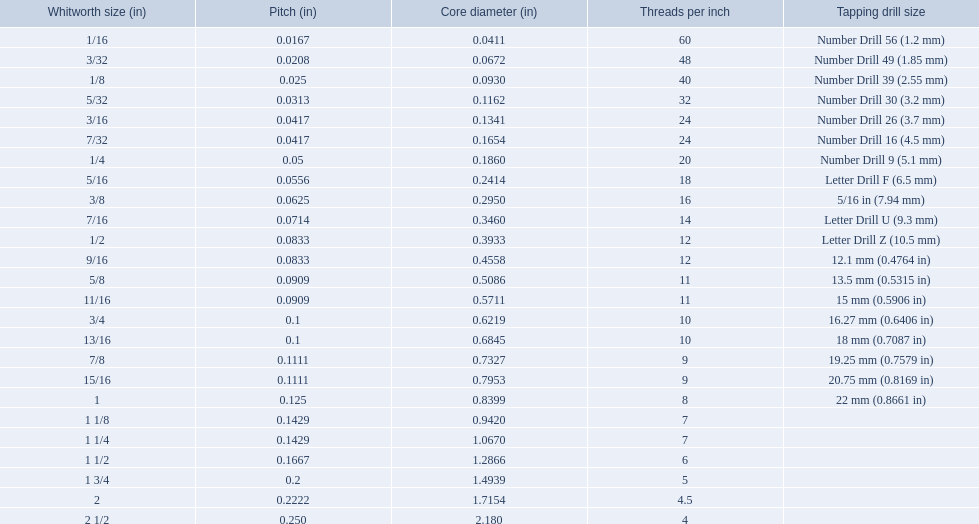What are all the whitworth sizes? 1/16, 3/32, 1/8, 5/32, 3/16, 7/32, 1/4, 5/16, 3/8, 7/16, 1/2, 9/16, 5/8, 11/16, 3/4, 13/16, 7/8, 15/16, 1, 1 1/8, 1 1/4, 1 1/2, 1 3/4, 2, 2 1/2. Can you give me this table as a dict? {'header': ['Whitworth size (in)', 'Pitch (in)', 'Core diameter (in)', 'Threads per\xa0inch', 'Tapping drill size'], 'rows': [['1/16', '0.0167', '0.0411', '60', 'Number Drill 56 (1.2\xa0mm)'], ['3/32', '0.0208', '0.0672', '48', 'Number Drill 49 (1.85\xa0mm)'], ['1/8', '0.025', '0.0930', '40', 'Number Drill 39 (2.55\xa0mm)'], ['5/32', '0.0313', '0.1162', '32', 'Number Drill 30 (3.2\xa0mm)'], ['3/16', '0.0417', '0.1341', '24', 'Number Drill 26 (3.7\xa0mm)'], ['7/32', '0.0417', '0.1654', '24', 'Number Drill 16 (4.5\xa0mm)'], ['1/4', '0.05', '0.1860', '20', 'Number Drill 9 (5.1\xa0mm)'], ['5/16', '0.0556', '0.2414', '18', 'Letter Drill F (6.5\xa0mm)'], ['3/8', '0.0625', '0.2950', '16', '5/16\xa0in (7.94\xa0mm)'], ['7/16', '0.0714', '0.3460', '14', 'Letter Drill U (9.3\xa0mm)'], ['1/2', '0.0833', '0.3933', '12', 'Letter Drill Z (10.5\xa0mm)'], ['9/16', '0.0833', '0.4558', '12', '12.1\xa0mm (0.4764\xa0in)'], ['5/8', '0.0909', '0.5086', '11', '13.5\xa0mm (0.5315\xa0in)'], ['11/16', '0.0909', '0.5711', '11', '15\xa0mm (0.5906\xa0in)'], ['3/4', '0.1', '0.6219', '10', '16.27\xa0mm (0.6406\xa0in)'], ['13/16', '0.1', '0.6845', '10', '18\xa0mm (0.7087\xa0in)'], ['7/8', '0.1111', '0.7327', '9', '19.25\xa0mm (0.7579\xa0in)'], ['15/16', '0.1111', '0.7953', '9', '20.75\xa0mm (0.8169\xa0in)'], ['1', '0.125', '0.8399', '8', '22\xa0mm (0.8661\xa0in)'], ['1 1/8', '0.1429', '0.9420', '7', ''], ['1 1/4', '0.1429', '1.0670', '7', ''], ['1 1/2', '0.1667', '1.2866', '6', ''], ['1 3/4', '0.2', '1.4939', '5', ''], ['2', '0.2222', '1.7154', '4.5', ''], ['2 1/2', '0.250', '2.180', '4', '']]} What are the threads per inch of these sizes? 60, 48, 40, 32, 24, 24, 20, 18, 16, 14, 12, 12, 11, 11, 10, 10, 9, 9, 8, 7, 7, 6, 5, 4.5, 4. Of these, which are 5? 5. What whitworth size has this threads per inch? 1 3/4. 